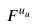<formula> <loc_0><loc_0><loc_500><loc_500>F ^ { u _ { u } }</formula> 